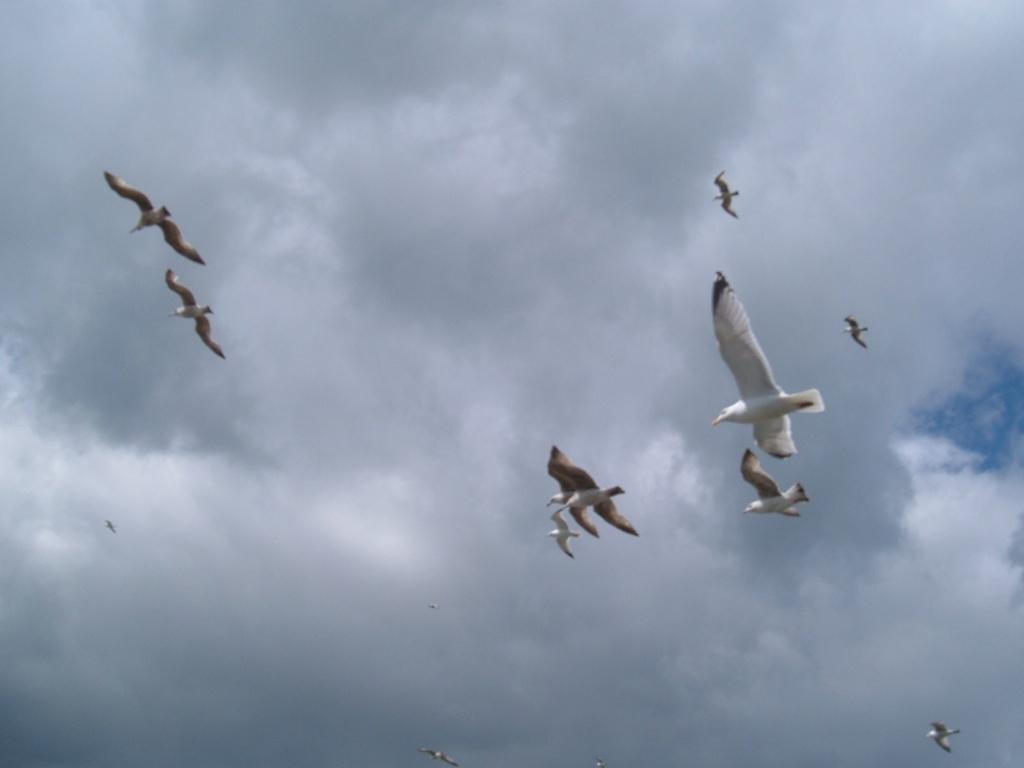What is happening in the image? There are birds flying in the image. What can be seen in the background of the image? The sky is visible in the background of the image. How would you describe the sky in the image? The sky is cloudy in the image. What type of disease can be seen affecting the birds in the image? There is no indication of any disease affecting the birds in the image; they are simply flying. Can you tell me how many beggars are present in the image? There are no beggars present in the image; it features birds flying in the sky. 